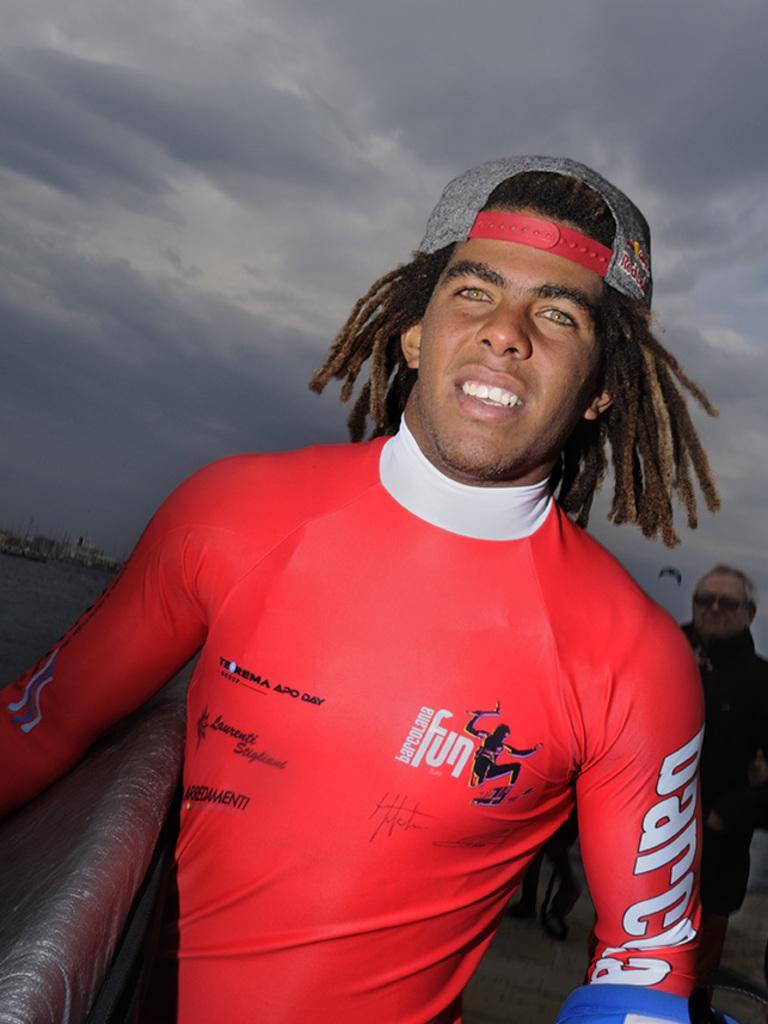Can you describe this image briefly? In the foreground of this image, there is a man standing near a railing and it seems like there are persons in the background are on the ship. In the background, there is water, few buildings, sky and the cloud. 